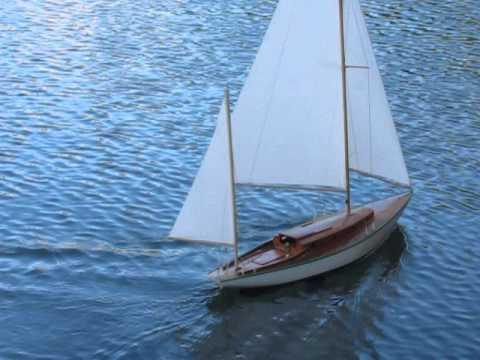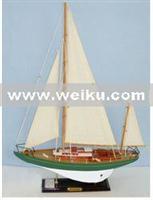The first image is the image on the left, the second image is the image on the right. Evaluate the accuracy of this statement regarding the images: "An image shows at least one undocked boat surrounded by water.". Is it true? Answer yes or no. Yes. 